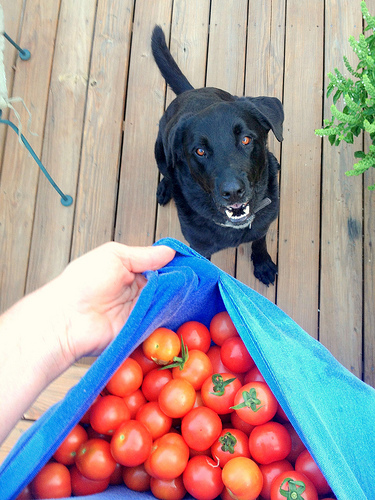<image>
Is the dog in front of the tomato? No. The dog is not in front of the tomato. The spatial positioning shows a different relationship between these objects. Is there a dog above the tomato? No. The dog is not positioned above the tomato. The vertical arrangement shows a different relationship. 